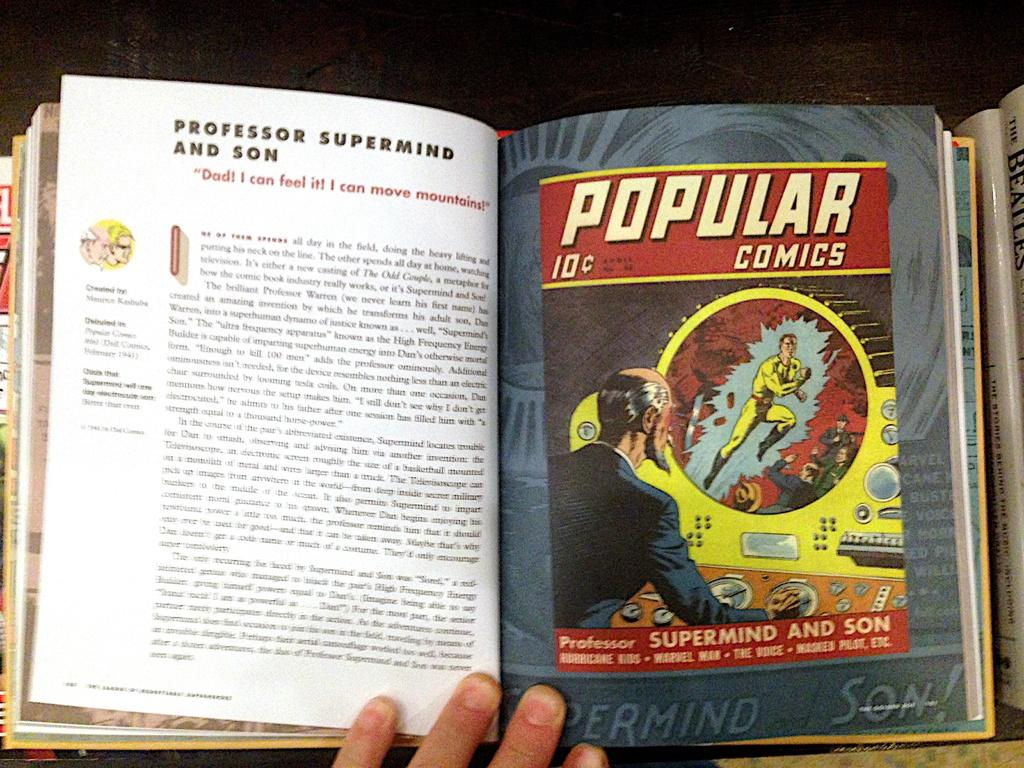<image>
Present a compact description of the photo's key features. A copy of Popular Comics has been bound into a book with other comics. 